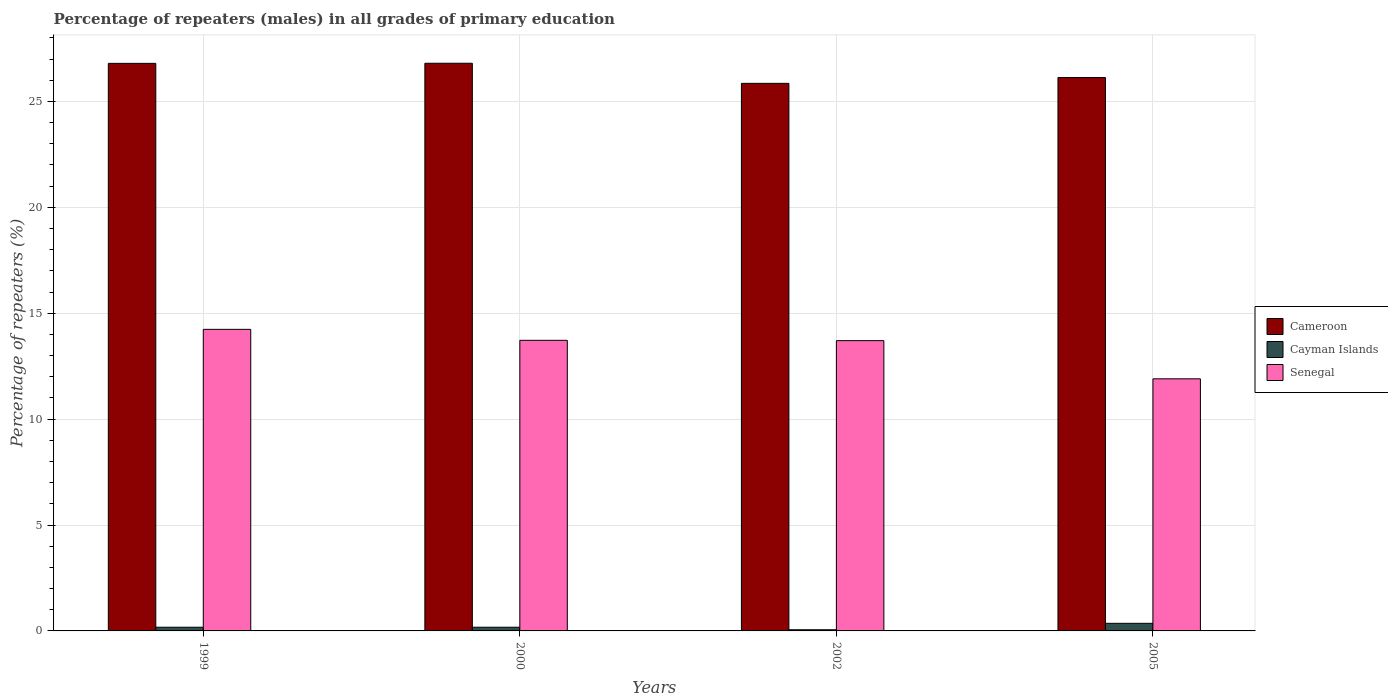How many groups of bars are there?
Your answer should be compact. 4. Are the number of bars on each tick of the X-axis equal?
Ensure brevity in your answer.  Yes. How many bars are there on the 4th tick from the right?
Make the answer very short. 3. What is the label of the 2nd group of bars from the left?
Provide a succinct answer. 2000. What is the percentage of repeaters (males) in Senegal in 1999?
Keep it short and to the point. 14.24. Across all years, what is the maximum percentage of repeaters (males) in Senegal?
Your answer should be compact. 14.24. Across all years, what is the minimum percentage of repeaters (males) in Senegal?
Your answer should be very brief. 11.9. What is the total percentage of repeaters (males) in Senegal in the graph?
Provide a succinct answer. 53.56. What is the difference between the percentage of repeaters (males) in Cayman Islands in 1999 and that in 2000?
Your response must be concise. 0. What is the difference between the percentage of repeaters (males) in Senegal in 2005 and the percentage of repeaters (males) in Cayman Islands in 1999?
Your answer should be compact. 11.73. What is the average percentage of repeaters (males) in Cameroon per year?
Offer a terse response. 26.39. In the year 2000, what is the difference between the percentage of repeaters (males) in Senegal and percentage of repeaters (males) in Cameroon?
Give a very brief answer. -13.08. In how many years, is the percentage of repeaters (males) in Senegal greater than 22 %?
Provide a short and direct response. 0. What is the ratio of the percentage of repeaters (males) in Cayman Islands in 1999 to that in 2005?
Give a very brief answer. 0.49. Is the difference between the percentage of repeaters (males) in Senegal in 2000 and 2002 greater than the difference between the percentage of repeaters (males) in Cameroon in 2000 and 2002?
Your response must be concise. No. What is the difference between the highest and the second highest percentage of repeaters (males) in Senegal?
Provide a short and direct response. 0.52. What is the difference between the highest and the lowest percentage of repeaters (males) in Cayman Islands?
Your answer should be compact. 0.3. In how many years, is the percentage of repeaters (males) in Cameroon greater than the average percentage of repeaters (males) in Cameroon taken over all years?
Give a very brief answer. 2. What does the 2nd bar from the left in 2002 represents?
Make the answer very short. Cayman Islands. What does the 1st bar from the right in 2005 represents?
Provide a succinct answer. Senegal. Is it the case that in every year, the sum of the percentage of repeaters (males) in Cameroon and percentage of repeaters (males) in Cayman Islands is greater than the percentage of repeaters (males) in Senegal?
Make the answer very short. Yes. How many bars are there?
Ensure brevity in your answer.  12. How many years are there in the graph?
Provide a short and direct response. 4. Does the graph contain any zero values?
Offer a terse response. No. Where does the legend appear in the graph?
Your answer should be compact. Center right. How many legend labels are there?
Provide a short and direct response. 3. How are the legend labels stacked?
Your response must be concise. Vertical. What is the title of the graph?
Your response must be concise. Percentage of repeaters (males) in all grades of primary education. Does "Azerbaijan" appear as one of the legend labels in the graph?
Provide a short and direct response. No. What is the label or title of the X-axis?
Make the answer very short. Years. What is the label or title of the Y-axis?
Keep it short and to the point. Percentage of repeaters (%). What is the Percentage of repeaters (%) in Cameroon in 1999?
Provide a succinct answer. 26.8. What is the Percentage of repeaters (%) in Cayman Islands in 1999?
Offer a very short reply. 0.17. What is the Percentage of repeaters (%) in Senegal in 1999?
Offer a terse response. 14.24. What is the Percentage of repeaters (%) in Cameroon in 2000?
Your answer should be very brief. 26.8. What is the Percentage of repeaters (%) of Cayman Islands in 2000?
Keep it short and to the point. 0.17. What is the Percentage of repeaters (%) of Senegal in 2000?
Your answer should be compact. 13.72. What is the Percentage of repeaters (%) of Cameroon in 2002?
Ensure brevity in your answer.  25.85. What is the Percentage of repeaters (%) in Cayman Islands in 2002?
Provide a succinct answer. 0.06. What is the Percentage of repeaters (%) of Senegal in 2002?
Provide a short and direct response. 13.7. What is the Percentage of repeaters (%) of Cameroon in 2005?
Ensure brevity in your answer.  26.13. What is the Percentage of repeaters (%) in Cayman Islands in 2005?
Offer a very short reply. 0.36. What is the Percentage of repeaters (%) in Senegal in 2005?
Give a very brief answer. 11.9. Across all years, what is the maximum Percentage of repeaters (%) in Cameroon?
Your answer should be compact. 26.8. Across all years, what is the maximum Percentage of repeaters (%) of Cayman Islands?
Keep it short and to the point. 0.36. Across all years, what is the maximum Percentage of repeaters (%) in Senegal?
Offer a terse response. 14.24. Across all years, what is the minimum Percentage of repeaters (%) of Cameroon?
Offer a very short reply. 25.85. Across all years, what is the minimum Percentage of repeaters (%) of Cayman Islands?
Offer a very short reply. 0.06. Across all years, what is the minimum Percentage of repeaters (%) of Senegal?
Your answer should be very brief. 11.9. What is the total Percentage of repeaters (%) of Cameroon in the graph?
Provide a short and direct response. 105.58. What is the total Percentage of repeaters (%) of Cayman Islands in the graph?
Provide a short and direct response. 0.76. What is the total Percentage of repeaters (%) of Senegal in the graph?
Give a very brief answer. 53.56. What is the difference between the Percentage of repeaters (%) in Cameroon in 1999 and that in 2000?
Offer a terse response. -0.01. What is the difference between the Percentage of repeaters (%) of Senegal in 1999 and that in 2000?
Keep it short and to the point. 0.52. What is the difference between the Percentage of repeaters (%) of Cameroon in 1999 and that in 2002?
Give a very brief answer. 0.94. What is the difference between the Percentage of repeaters (%) of Cayman Islands in 1999 and that in 2002?
Offer a very short reply. 0.12. What is the difference between the Percentage of repeaters (%) of Senegal in 1999 and that in 2002?
Your response must be concise. 0.53. What is the difference between the Percentage of repeaters (%) in Cameroon in 1999 and that in 2005?
Offer a very short reply. 0.67. What is the difference between the Percentage of repeaters (%) in Cayman Islands in 1999 and that in 2005?
Make the answer very short. -0.18. What is the difference between the Percentage of repeaters (%) in Senegal in 1999 and that in 2005?
Offer a very short reply. 2.34. What is the difference between the Percentage of repeaters (%) of Cameroon in 2000 and that in 2002?
Keep it short and to the point. 0.95. What is the difference between the Percentage of repeaters (%) of Cayman Islands in 2000 and that in 2002?
Your response must be concise. 0.12. What is the difference between the Percentage of repeaters (%) of Senegal in 2000 and that in 2002?
Your answer should be compact. 0.02. What is the difference between the Percentage of repeaters (%) of Cameroon in 2000 and that in 2005?
Provide a succinct answer. 0.67. What is the difference between the Percentage of repeaters (%) in Cayman Islands in 2000 and that in 2005?
Provide a succinct answer. -0.18. What is the difference between the Percentage of repeaters (%) in Senegal in 2000 and that in 2005?
Offer a terse response. 1.82. What is the difference between the Percentage of repeaters (%) in Cameroon in 2002 and that in 2005?
Your answer should be very brief. -0.27. What is the difference between the Percentage of repeaters (%) of Cayman Islands in 2002 and that in 2005?
Your answer should be compact. -0.3. What is the difference between the Percentage of repeaters (%) in Senegal in 2002 and that in 2005?
Ensure brevity in your answer.  1.8. What is the difference between the Percentage of repeaters (%) in Cameroon in 1999 and the Percentage of repeaters (%) in Cayman Islands in 2000?
Your response must be concise. 26.62. What is the difference between the Percentage of repeaters (%) of Cameroon in 1999 and the Percentage of repeaters (%) of Senegal in 2000?
Make the answer very short. 13.08. What is the difference between the Percentage of repeaters (%) of Cayman Islands in 1999 and the Percentage of repeaters (%) of Senegal in 2000?
Your response must be concise. -13.55. What is the difference between the Percentage of repeaters (%) of Cameroon in 1999 and the Percentage of repeaters (%) of Cayman Islands in 2002?
Provide a succinct answer. 26.74. What is the difference between the Percentage of repeaters (%) in Cameroon in 1999 and the Percentage of repeaters (%) in Senegal in 2002?
Ensure brevity in your answer.  13.09. What is the difference between the Percentage of repeaters (%) of Cayman Islands in 1999 and the Percentage of repeaters (%) of Senegal in 2002?
Provide a short and direct response. -13.53. What is the difference between the Percentage of repeaters (%) in Cameroon in 1999 and the Percentage of repeaters (%) in Cayman Islands in 2005?
Make the answer very short. 26.44. What is the difference between the Percentage of repeaters (%) of Cameroon in 1999 and the Percentage of repeaters (%) of Senegal in 2005?
Make the answer very short. 14.89. What is the difference between the Percentage of repeaters (%) of Cayman Islands in 1999 and the Percentage of repeaters (%) of Senegal in 2005?
Make the answer very short. -11.73. What is the difference between the Percentage of repeaters (%) of Cameroon in 2000 and the Percentage of repeaters (%) of Cayman Islands in 2002?
Provide a succinct answer. 26.75. What is the difference between the Percentage of repeaters (%) of Cameroon in 2000 and the Percentage of repeaters (%) of Senegal in 2002?
Your answer should be very brief. 13.1. What is the difference between the Percentage of repeaters (%) in Cayman Islands in 2000 and the Percentage of repeaters (%) in Senegal in 2002?
Offer a terse response. -13.53. What is the difference between the Percentage of repeaters (%) in Cameroon in 2000 and the Percentage of repeaters (%) in Cayman Islands in 2005?
Give a very brief answer. 26.44. What is the difference between the Percentage of repeaters (%) in Cameroon in 2000 and the Percentage of repeaters (%) in Senegal in 2005?
Ensure brevity in your answer.  14.9. What is the difference between the Percentage of repeaters (%) in Cayman Islands in 2000 and the Percentage of repeaters (%) in Senegal in 2005?
Give a very brief answer. -11.73. What is the difference between the Percentage of repeaters (%) of Cameroon in 2002 and the Percentage of repeaters (%) of Cayman Islands in 2005?
Your answer should be compact. 25.49. What is the difference between the Percentage of repeaters (%) of Cameroon in 2002 and the Percentage of repeaters (%) of Senegal in 2005?
Your response must be concise. 13.95. What is the difference between the Percentage of repeaters (%) of Cayman Islands in 2002 and the Percentage of repeaters (%) of Senegal in 2005?
Your answer should be compact. -11.85. What is the average Percentage of repeaters (%) of Cameroon per year?
Provide a succinct answer. 26.39. What is the average Percentage of repeaters (%) in Cayman Islands per year?
Provide a succinct answer. 0.19. What is the average Percentage of repeaters (%) in Senegal per year?
Provide a short and direct response. 13.39. In the year 1999, what is the difference between the Percentage of repeaters (%) of Cameroon and Percentage of repeaters (%) of Cayman Islands?
Keep it short and to the point. 26.62. In the year 1999, what is the difference between the Percentage of repeaters (%) of Cameroon and Percentage of repeaters (%) of Senegal?
Your response must be concise. 12.56. In the year 1999, what is the difference between the Percentage of repeaters (%) of Cayman Islands and Percentage of repeaters (%) of Senegal?
Make the answer very short. -14.06. In the year 2000, what is the difference between the Percentage of repeaters (%) in Cameroon and Percentage of repeaters (%) in Cayman Islands?
Ensure brevity in your answer.  26.63. In the year 2000, what is the difference between the Percentage of repeaters (%) of Cameroon and Percentage of repeaters (%) of Senegal?
Keep it short and to the point. 13.08. In the year 2000, what is the difference between the Percentage of repeaters (%) of Cayman Islands and Percentage of repeaters (%) of Senegal?
Offer a terse response. -13.55. In the year 2002, what is the difference between the Percentage of repeaters (%) of Cameroon and Percentage of repeaters (%) of Cayman Islands?
Ensure brevity in your answer.  25.8. In the year 2002, what is the difference between the Percentage of repeaters (%) of Cameroon and Percentage of repeaters (%) of Senegal?
Ensure brevity in your answer.  12.15. In the year 2002, what is the difference between the Percentage of repeaters (%) in Cayman Islands and Percentage of repeaters (%) in Senegal?
Your answer should be very brief. -13.65. In the year 2005, what is the difference between the Percentage of repeaters (%) in Cameroon and Percentage of repeaters (%) in Cayman Islands?
Offer a terse response. 25.77. In the year 2005, what is the difference between the Percentage of repeaters (%) of Cameroon and Percentage of repeaters (%) of Senegal?
Provide a succinct answer. 14.23. In the year 2005, what is the difference between the Percentage of repeaters (%) in Cayman Islands and Percentage of repeaters (%) in Senegal?
Provide a succinct answer. -11.54. What is the ratio of the Percentage of repeaters (%) in Cayman Islands in 1999 to that in 2000?
Offer a very short reply. 1. What is the ratio of the Percentage of repeaters (%) in Senegal in 1999 to that in 2000?
Your answer should be compact. 1.04. What is the ratio of the Percentage of repeaters (%) of Cameroon in 1999 to that in 2002?
Give a very brief answer. 1.04. What is the ratio of the Percentage of repeaters (%) in Cayman Islands in 1999 to that in 2002?
Provide a succinct answer. 3.16. What is the ratio of the Percentage of repeaters (%) in Senegal in 1999 to that in 2002?
Your answer should be compact. 1.04. What is the ratio of the Percentage of repeaters (%) in Cameroon in 1999 to that in 2005?
Give a very brief answer. 1.03. What is the ratio of the Percentage of repeaters (%) of Cayman Islands in 1999 to that in 2005?
Keep it short and to the point. 0.49. What is the ratio of the Percentage of repeaters (%) of Senegal in 1999 to that in 2005?
Ensure brevity in your answer.  1.2. What is the ratio of the Percentage of repeaters (%) in Cameroon in 2000 to that in 2002?
Offer a terse response. 1.04. What is the ratio of the Percentage of repeaters (%) of Cayman Islands in 2000 to that in 2002?
Ensure brevity in your answer.  3.16. What is the ratio of the Percentage of repeaters (%) in Senegal in 2000 to that in 2002?
Offer a very short reply. 1. What is the ratio of the Percentage of repeaters (%) of Cameroon in 2000 to that in 2005?
Make the answer very short. 1.03. What is the ratio of the Percentage of repeaters (%) of Cayman Islands in 2000 to that in 2005?
Give a very brief answer. 0.49. What is the ratio of the Percentage of repeaters (%) of Senegal in 2000 to that in 2005?
Your response must be concise. 1.15. What is the ratio of the Percentage of repeaters (%) in Cameroon in 2002 to that in 2005?
Offer a terse response. 0.99. What is the ratio of the Percentage of repeaters (%) in Cayman Islands in 2002 to that in 2005?
Your answer should be very brief. 0.15. What is the ratio of the Percentage of repeaters (%) of Senegal in 2002 to that in 2005?
Provide a short and direct response. 1.15. What is the difference between the highest and the second highest Percentage of repeaters (%) of Cameroon?
Give a very brief answer. 0.01. What is the difference between the highest and the second highest Percentage of repeaters (%) of Cayman Islands?
Make the answer very short. 0.18. What is the difference between the highest and the second highest Percentage of repeaters (%) in Senegal?
Make the answer very short. 0.52. What is the difference between the highest and the lowest Percentage of repeaters (%) of Cameroon?
Your answer should be very brief. 0.95. What is the difference between the highest and the lowest Percentage of repeaters (%) of Cayman Islands?
Your answer should be compact. 0.3. What is the difference between the highest and the lowest Percentage of repeaters (%) of Senegal?
Provide a succinct answer. 2.34. 